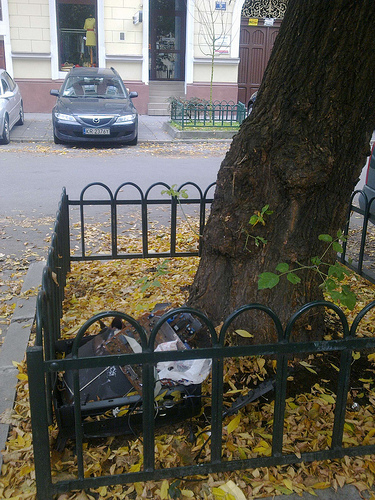<image>
Can you confirm if the yellow dress is in front of the car? No. The yellow dress is not in front of the car. The spatial positioning shows a different relationship between these objects. 